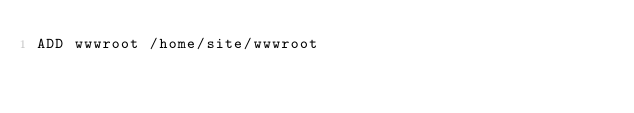Convert code to text. <code><loc_0><loc_0><loc_500><loc_500><_Dockerfile_>ADD wwwroot /home/site/wwwroot</code> 